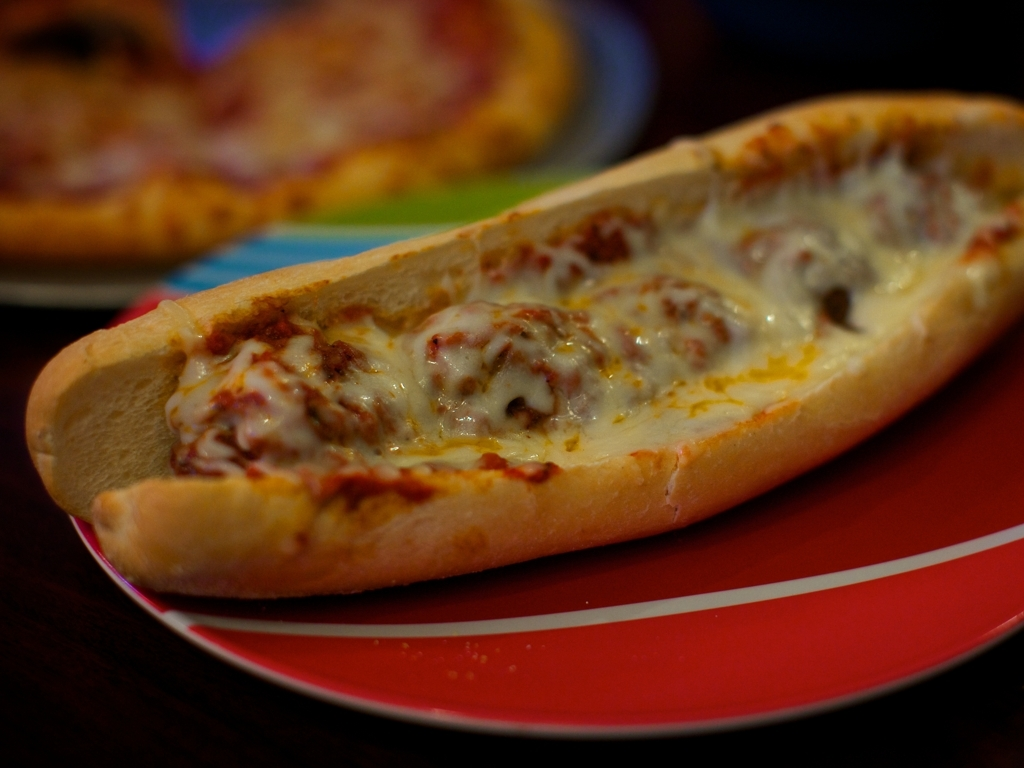Describe the setting in which the sandwich is placed. The sandwich is placed on a bright red plate, which provides a striking contrast to the golden-brown color of the toasted bun. The plate itself sits on a dark wooden table, and in the background, there appears to be another dish with a portion of pizza, suggesting a casual dining atmosphere. 